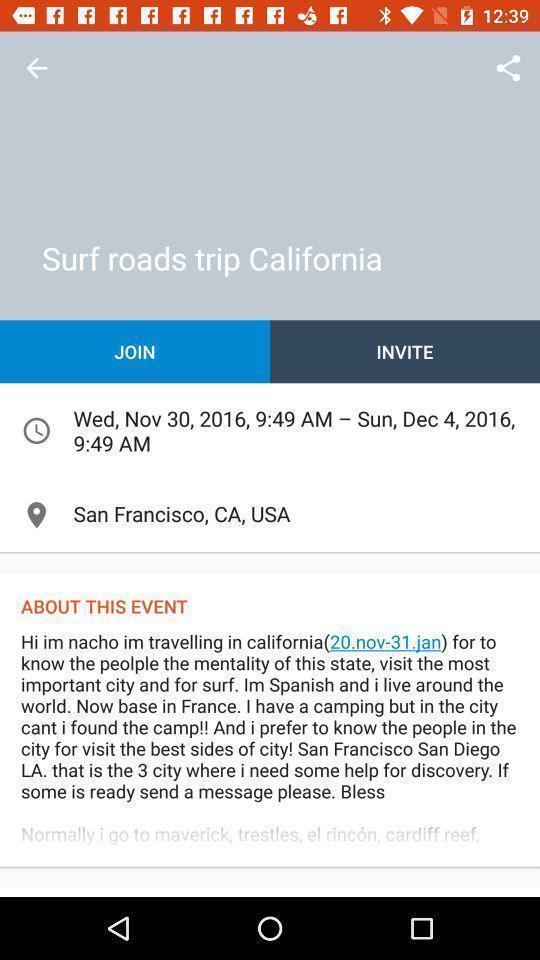Describe this image in words. Screen displaying details of an event. 